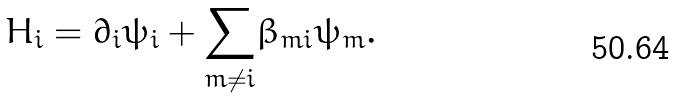<formula> <loc_0><loc_0><loc_500><loc_500>H _ { i } = \partial _ { i } \psi _ { i } + \underset { m \neq i } { \sum } \beta _ { m i } \psi _ { m } .</formula> 